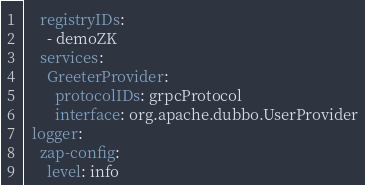Convert code to text. <code><loc_0><loc_0><loc_500><loc_500><_YAML_>    registryIDs:
      - demoZK
    services:
      GreeterProvider:
        protocolIDs: grpcProtocol
        interface: org.apache.dubbo.UserProvider
  logger:
    zap-config:
      level: info</code> 